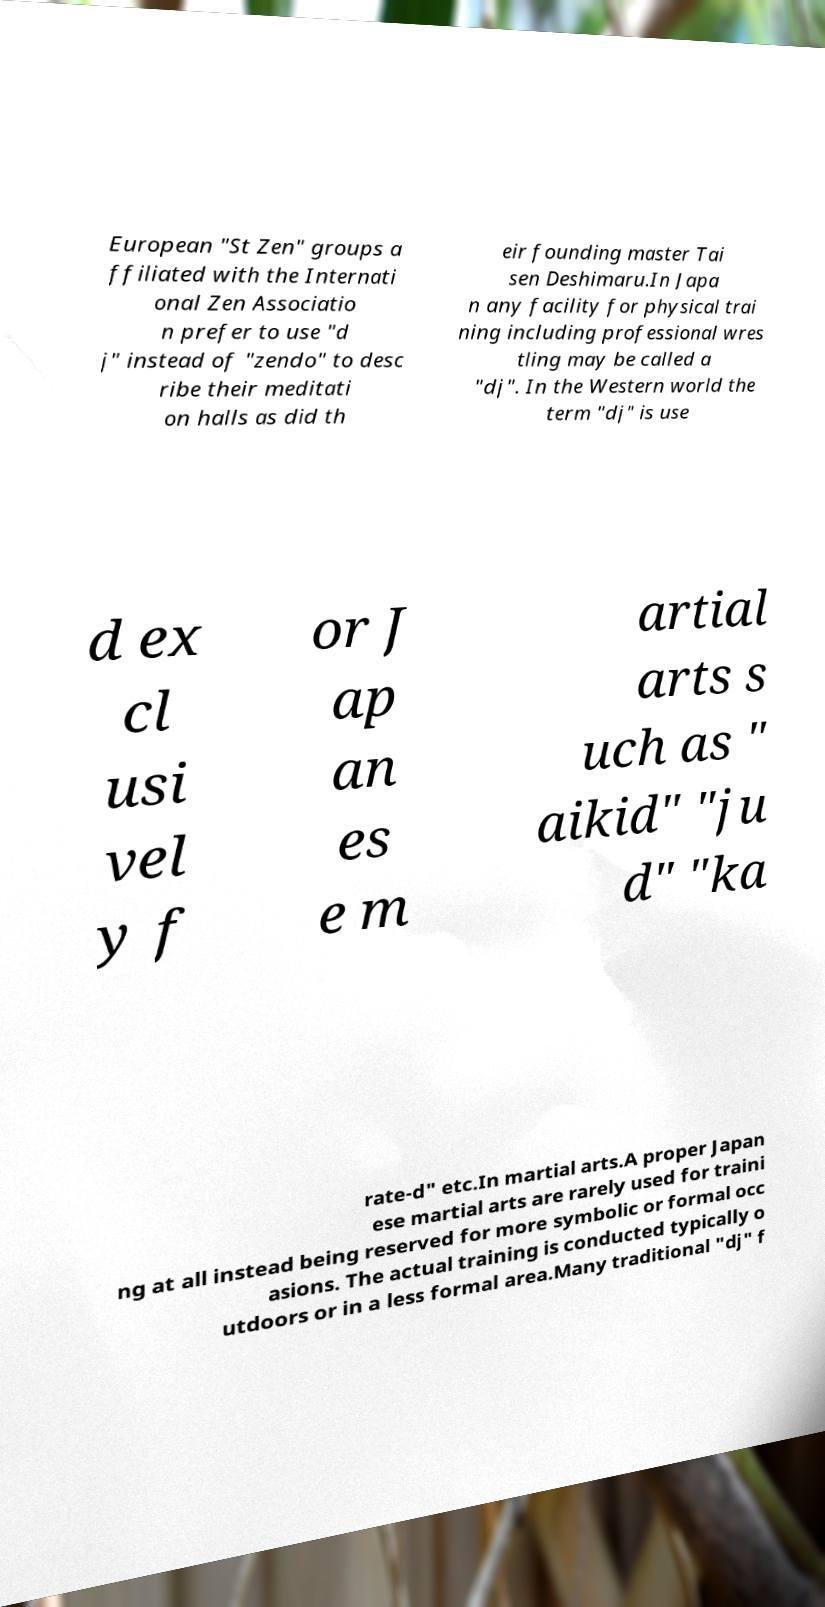Please identify and transcribe the text found in this image. European "St Zen" groups a ffiliated with the Internati onal Zen Associatio n prefer to use "d j" instead of "zendo" to desc ribe their meditati on halls as did th eir founding master Tai sen Deshimaru.In Japa n any facility for physical trai ning including professional wres tling may be called a "dj". In the Western world the term "dj" is use d ex cl usi vel y f or J ap an es e m artial arts s uch as " aikid" "ju d" "ka rate-d" etc.In martial arts.A proper Japan ese martial arts are rarely used for traini ng at all instead being reserved for more symbolic or formal occ asions. The actual training is conducted typically o utdoors or in a less formal area.Many traditional "dj" f 